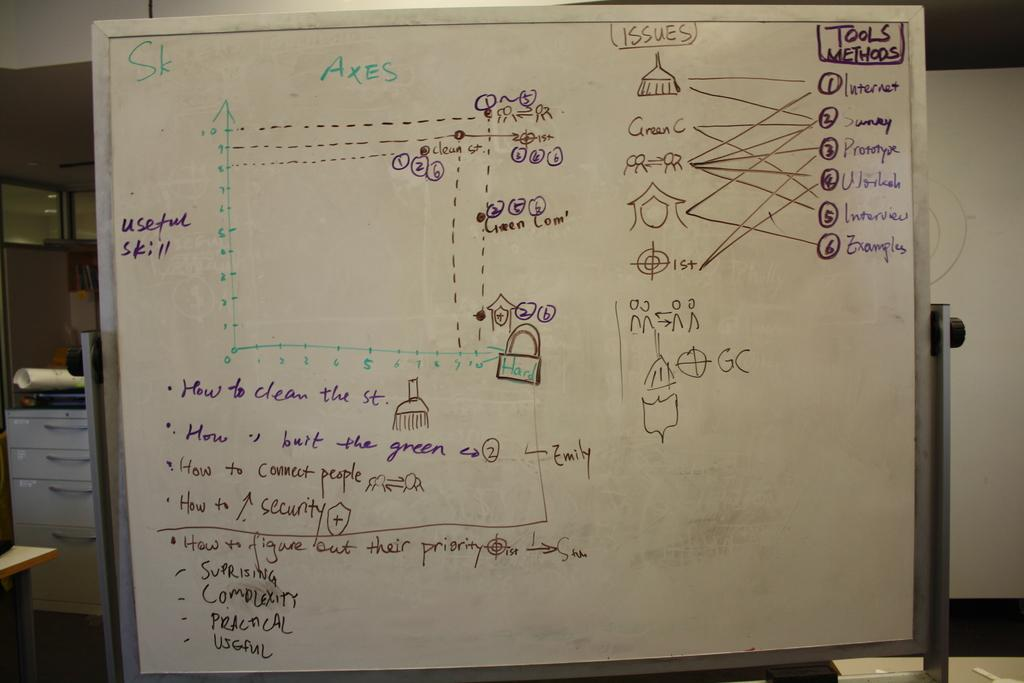<image>
Write a terse but informative summary of the picture. Notes drawn on a white board show tools and methods. 